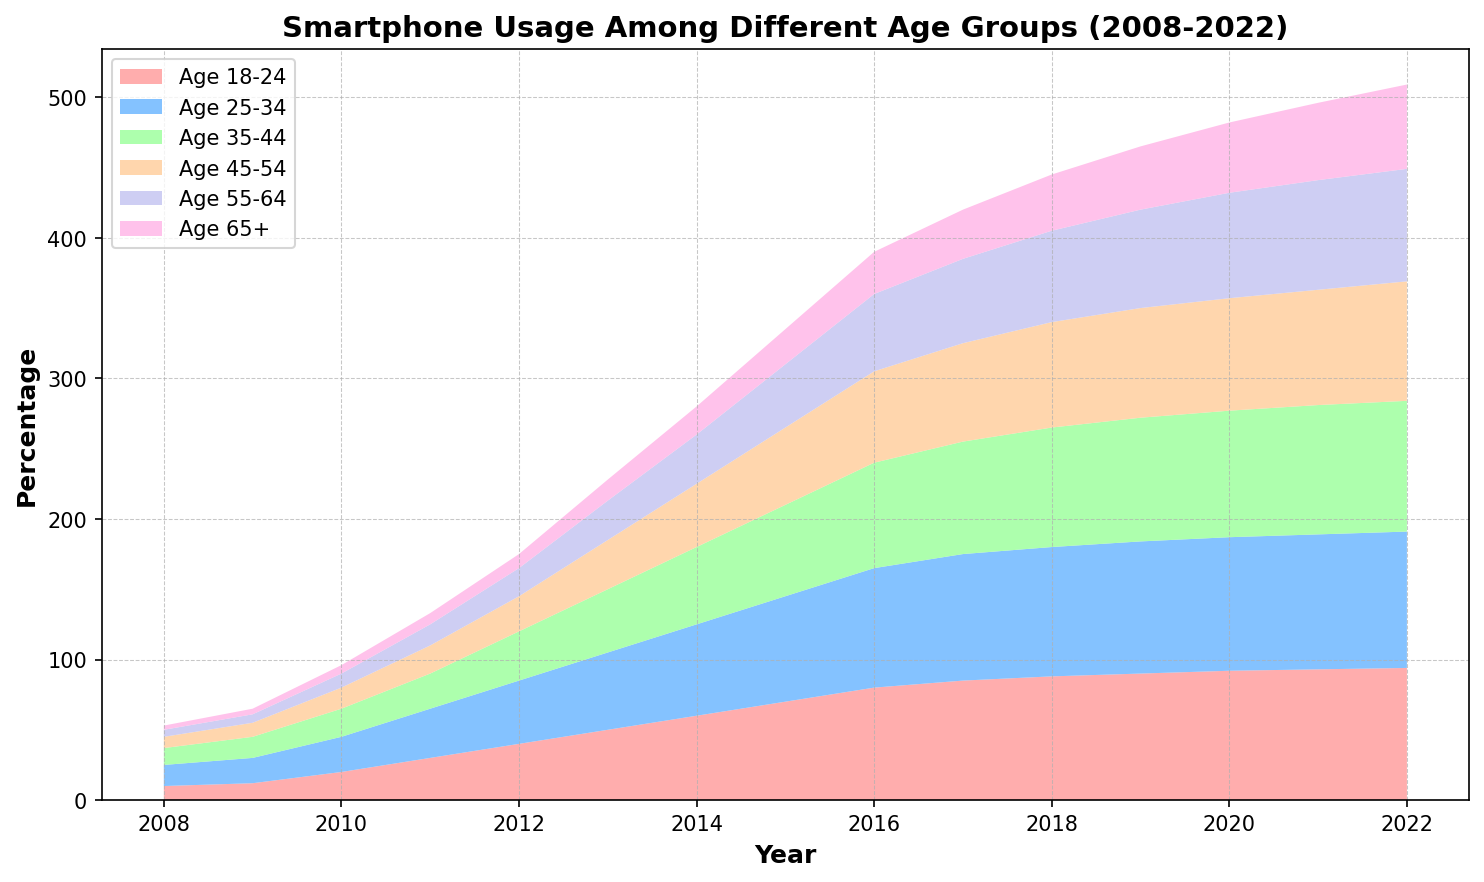What is the percentage of smartphone usage among the 45-54 age group in 2015? Locate the year 2015 on the x-axis. Find the corresponding stack segment for the 45-54 age group, which is represented by the color between the 35-44 and 55-64 age groups. The percentage is 55%.
Answer: 55% Between which years did the 18-24 age group see the largest increase in smartphone usage? Observe the increasing slope of the 18-24 age group segment (the bottom-most layer). The steepest increase occurs between 2010 and 2011, where the jump is from 20% to 30%.
Answer: 2010 to 2011 Which age group had the smallest increase in smartphone usage between 2008 and 2022? Look at the difference in heights for each age group from 2008 to 2022. The 65+ age group has the smallest increase, going from 3% to 60%.
Answer: Age 65+ In what year did the 25-34 age group surpass 50% smartphone usage? Find the 25-34 age group segment (second from the bottom) and trace where it first crosses the 50% mark on the y-axis. This happens in 2013.
Answer: 2013 Which age group had the fastest growth in smartphone usage after 2015? Examine the rates of increase for all age groups after 2015. The 65+ age group (top layer) shows the steepest growth, increasing significantly from 25% in 2015 to 60% in 2022.
Answer: Age 65+ How did smartphone usage among the 55-64 age group change between 2017 and 2020? Look at the 55-64 age group segment (second from the top) in 2017 and 2020 and observe the change in heights. It increased from 60% to 75%.
Answer: Increased by 15% Which two age groups had the closest smartphone usage percentages in 2022? Check the ending points (2022) for all age groups and compare. The 45-54 and 35-44 age groups have very close percentages, at 85% and 93% respectively.
Answer: Age 45-54 and Age 35-44 In what year did smartphone usage among the 18-24 age group reach 90%? Find the 18-24 age group segment and trace when it crosses the 90% mark on the y-axis. This occurs in 2019.
Answer: 2019 For the year 2020, compare the smartphone usage between the 18-24 and 45-54 age groups. Which is higher and by how much? For 2020, note that the 18-24 age group is at 92%, and the 45-54 age group is at 80%. 92% - 80% = 12%.
Answer: 18-24 age group is higher by 12% By how much did smartphone usage among the 35-44 age group increase from 2008 to 2012? The 35-44 age group segment shows an increase from 12% in 2008 to 35% in 2012. 35% - 12% = 23%.
Answer: Increased by 23% 